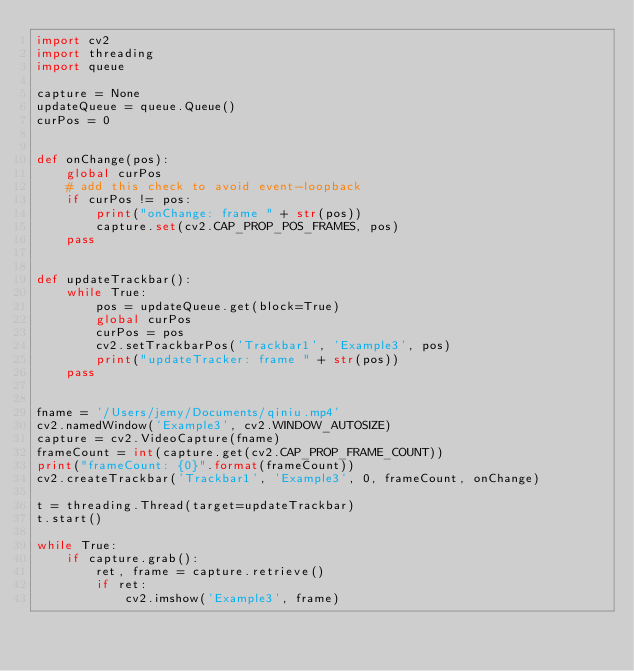<code> <loc_0><loc_0><loc_500><loc_500><_Python_>import cv2
import threading
import queue

capture = None
updateQueue = queue.Queue()
curPos = 0


def onChange(pos):
    global curPos
    # add this check to avoid event-loopback
    if curPos != pos:
        print("onChange: frame " + str(pos))
        capture.set(cv2.CAP_PROP_POS_FRAMES, pos)
    pass


def updateTrackbar():
    while True:
        pos = updateQueue.get(block=True)
        global curPos
        curPos = pos
        cv2.setTrackbarPos('Trackbar1', 'Example3', pos)
        print("updateTracker: frame " + str(pos))
    pass


fname = '/Users/jemy/Documents/qiniu.mp4'
cv2.namedWindow('Example3', cv2.WINDOW_AUTOSIZE)
capture = cv2.VideoCapture(fname)
frameCount = int(capture.get(cv2.CAP_PROP_FRAME_COUNT))
print("frameCount: {0}".format(frameCount))
cv2.createTrackbar('Trackbar1', 'Example3', 0, frameCount, onChange)

t = threading.Thread(target=updateTrackbar)
t.start()

while True:
    if capture.grab():
        ret, frame = capture.retrieve()
        if ret:
            cv2.imshow('Example3', frame)</code> 